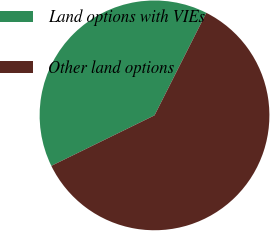Convert chart. <chart><loc_0><loc_0><loc_500><loc_500><pie_chart><fcel>Land options with VIEs<fcel>Other land options<nl><fcel>39.69%<fcel>60.31%<nl></chart> 